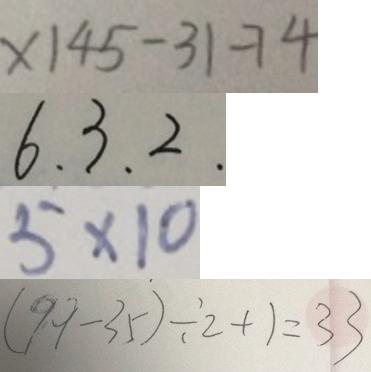<formula> <loc_0><loc_0><loc_500><loc_500>x 1 4 5 - 3 1 - 7 4 
 6 . 3 . 2 . 
 5 \times 1 0 
 ( 9 9 - 3 5 ) \div 2 + 1 = 3 3</formula> 